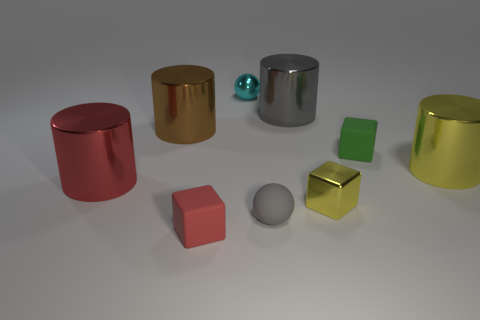Are there any big yellow objects that have the same shape as the red metal object?
Provide a short and direct response. Yes. What is the size of the gray object behind the yellow metal thing that is to the left of the yellow metallic cylinder?
Provide a short and direct response. Large. The brown metallic object has what shape?
Give a very brief answer. Cylinder. What material is the small thing that is to the left of the tiny cyan metallic sphere?
Offer a very short reply. Rubber. What color is the sphere behind the large cylinder that is in front of the large shiny cylinder right of the tiny green thing?
Make the answer very short. Cyan. What is the color of the shiny ball that is the same size as the yellow metal block?
Offer a terse response. Cyan. What number of matte things are small cyan spheres or red objects?
Ensure brevity in your answer.  1. The small block that is the same material as the green object is what color?
Offer a very short reply. Red. What material is the red thing that is behind the rubber block to the left of the tiny rubber sphere?
Keep it short and to the point. Metal. What number of things are tiny things to the left of the small green cube or tiny cubes that are to the right of the tiny yellow object?
Your response must be concise. 5. 